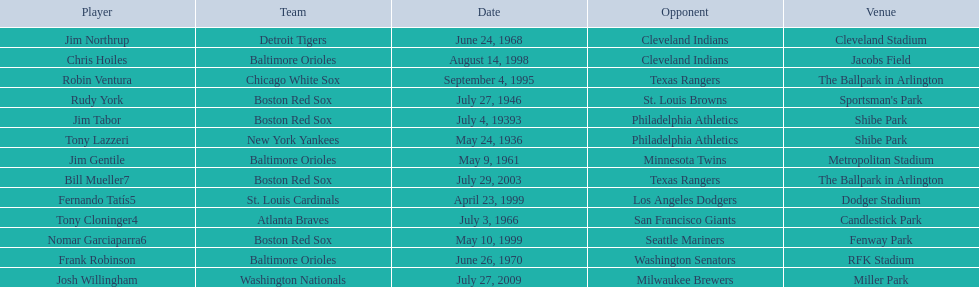I'm looking to parse the entire table for insights. Could you assist me with that? {'header': ['Player', 'Team', 'Date', 'Opponent', 'Venue'], 'rows': [['Jim Northrup', 'Detroit Tigers', 'June 24, 1968', 'Cleveland Indians', 'Cleveland Stadium'], ['Chris Hoiles', 'Baltimore Orioles', 'August 14, 1998', 'Cleveland Indians', 'Jacobs Field'], ['Robin Ventura', 'Chicago White Sox', 'September 4, 1995', 'Texas Rangers', 'The Ballpark in Arlington'], ['Rudy York', 'Boston Red Sox', 'July 27, 1946', 'St. Louis Browns', "Sportsman's Park"], ['Jim Tabor', 'Boston Red Sox', 'July 4, 19393', 'Philadelphia Athletics', 'Shibe Park'], ['Tony Lazzeri', 'New York Yankees', 'May 24, 1936', 'Philadelphia Athletics', 'Shibe Park'], ['Jim Gentile', 'Baltimore Orioles', 'May 9, 1961', 'Minnesota Twins', 'Metropolitan Stadium'], ['Bill Mueller7', 'Boston Red Sox', 'July 29, 2003', 'Texas Rangers', 'The Ballpark in Arlington'], ['Fernando Tatís5', 'St. Louis Cardinals', 'April 23, 1999', 'Los Angeles Dodgers', 'Dodger Stadium'], ['Tony Cloninger4', 'Atlanta Braves', 'July 3, 1966', 'San Francisco Giants', 'Candlestick Park'], ['Nomar Garciaparra6', 'Boston Red Sox', 'May 10, 1999', 'Seattle Mariners', 'Fenway Park'], ['Frank Robinson', 'Baltimore Orioles', 'June 26, 1970', 'Washington Senators', 'RFK Stadium'], ['Josh Willingham', 'Washington Nationals', 'July 27, 2009', 'Milwaukee Brewers', 'Miller Park']]} Who is the first major league hitter to hit two grand slams in one game? Tony Lazzeri. 